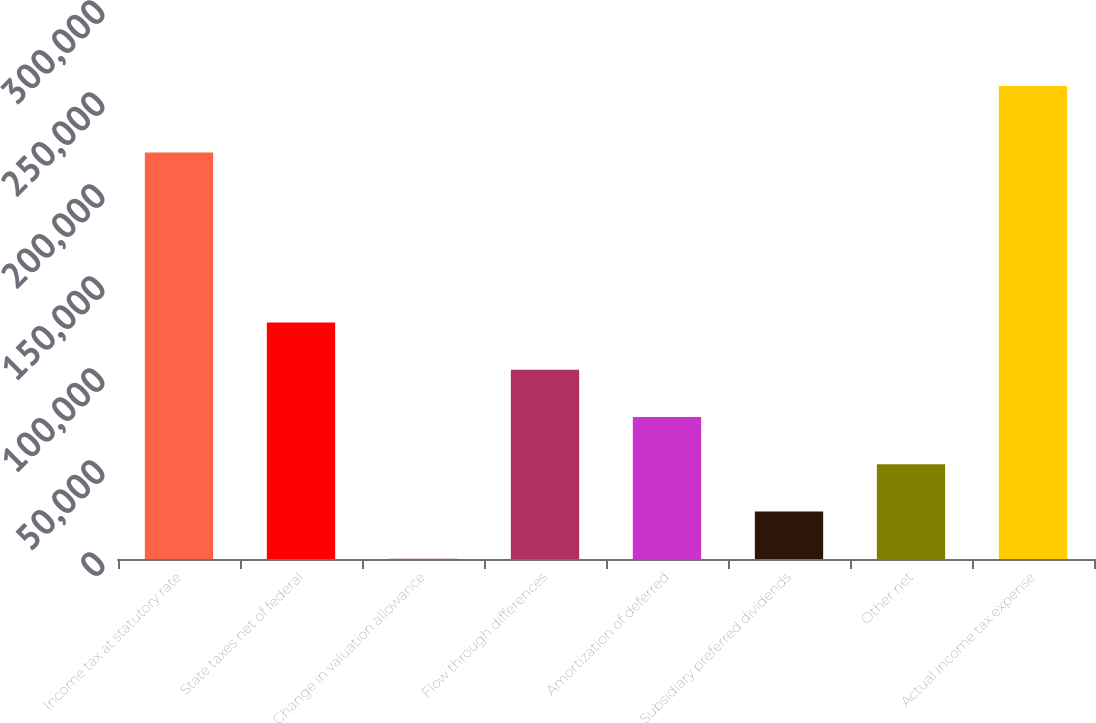Convert chart. <chart><loc_0><loc_0><loc_500><loc_500><bar_chart><fcel>Income tax at statutory rate<fcel>State taxes net of federal<fcel>Change in valuation allowance<fcel>Flow through differences<fcel>Amortization of deferred<fcel>Subsidiary preferred dividends<fcel>Other net<fcel>Actual income tax expense<nl><fcel>220940<fcel>128576<fcel>143<fcel>102889<fcel>77202.5<fcel>25829.5<fcel>51516<fcel>257008<nl></chart> 